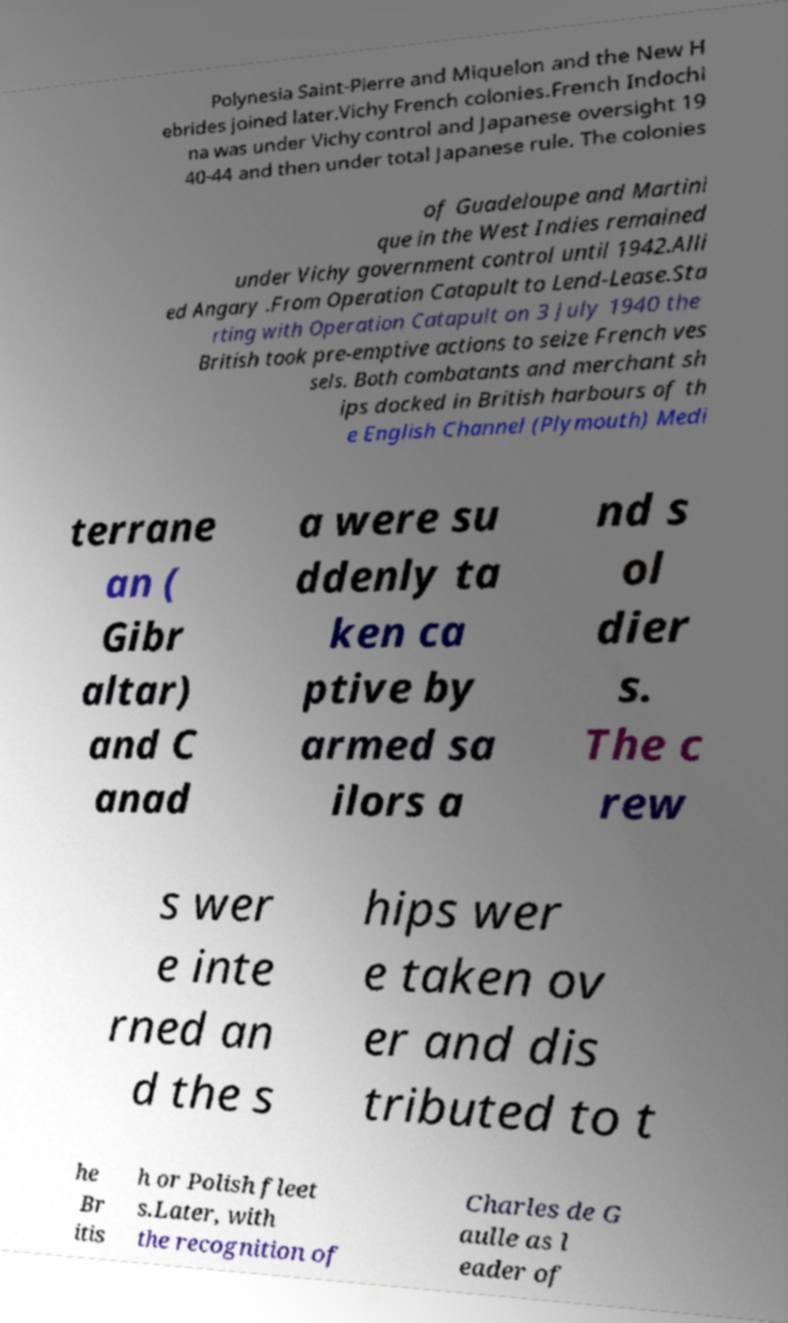Can you accurately transcribe the text from the provided image for me? Polynesia Saint-Pierre and Miquelon and the New H ebrides joined later.Vichy French colonies.French Indochi na was under Vichy control and Japanese oversight 19 40-44 and then under total Japanese rule. The colonies of Guadeloupe and Martini que in the West Indies remained under Vichy government control until 1942.Alli ed Angary .From Operation Catapult to Lend-Lease.Sta rting with Operation Catapult on 3 July 1940 the British took pre-emptive actions to seize French ves sels. Both combatants and merchant sh ips docked in British harbours of th e English Channel (Plymouth) Medi terrane an ( Gibr altar) and C anad a were su ddenly ta ken ca ptive by armed sa ilors a nd s ol dier s. The c rew s wer e inte rned an d the s hips wer e taken ov er and dis tributed to t he Br itis h or Polish fleet s.Later, with the recognition of Charles de G aulle as l eader of 